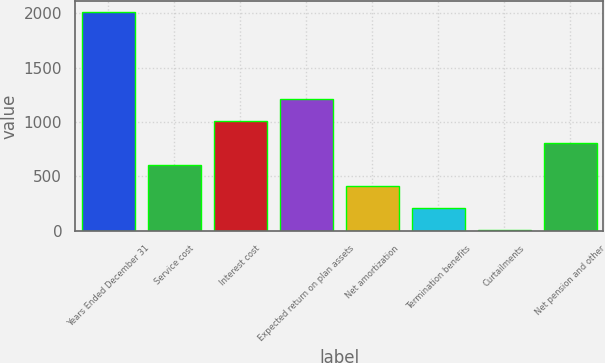Convert chart to OTSL. <chart><loc_0><loc_0><loc_500><loc_500><bar_chart><fcel>Years Ended December 31<fcel>Service cost<fcel>Interest cost<fcel>Expected return on plan assets<fcel>Net amortization<fcel>Termination benefits<fcel>Curtailments<fcel>Net pension and other<nl><fcel>2009<fcel>607.04<fcel>1007.6<fcel>1207.88<fcel>406.76<fcel>206.48<fcel>6.2<fcel>807.32<nl></chart> 